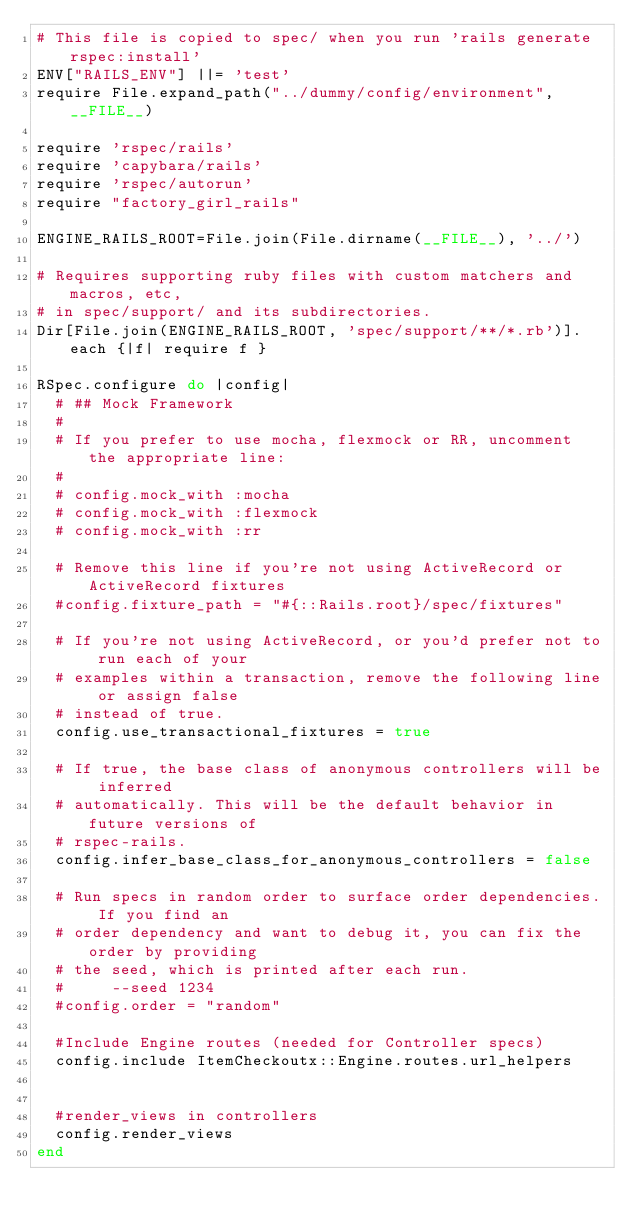Convert code to text. <code><loc_0><loc_0><loc_500><loc_500><_Ruby_># This file is copied to spec/ when you run 'rails generate rspec:install'
ENV["RAILS_ENV"] ||= 'test'
require File.expand_path("../dummy/config/environment", __FILE__)

require 'rspec/rails'
require 'capybara/rails'
require 'rspec/autorun'
require "factory_girl_rails"

ENGINE_RAILS_ROOT=File.join(File.dirname(__FILE__), '../')

# Requires supporting ruby files with custom matchers and macros, etc,
# in spec/support/ and its subdirectories.
Dir[File.join(ENGINE_RAILS_ROOT, 'spec/support/**/*.rb')].each {|f| require f }

RSpec.configure do |config|
  # ## Mock Framework
  #
  # If you prefer to use mocha, flexmock or RR, uncomment the appropriate line:
  #
  # config.mock_with :mocha
  # config.mock_with :flexmock
  # config.mock_with :rr

  # Remove this line if you're not using ActiveRecord or ActiveRecord fixtures
  #config.fixture_path = "#{::Rails.root}/spec/fixtures"

  # If you're not using ActiveRecord, or you'd prefer not to run each of your
  # examples within a transaction, remove the following line or assign false
  # instead of true.
  config.use_transactional_fixtures = true

  # If true, the base class of anonymous controllers will be inferred
  # automatically. This will be the default behavior in future versions of
  # rspec-rails.
  config.infer_base_class_for_anonymous_controllers = false

  # Run specs in random order to surface order dependencies. If you find an
  # order dependency and want to debug it, you can fix the order by providing
  # the seed, which is printed after each run.
  #     --seed 1234
  #config.order = "random"
  
  #Include Engine routes (needed for Controller specs)
  config.include ItemCheckoutx::Engine.routes.url_helpers
  
  
  #render_views in controllers  
  config.render_views    
end
</code> 